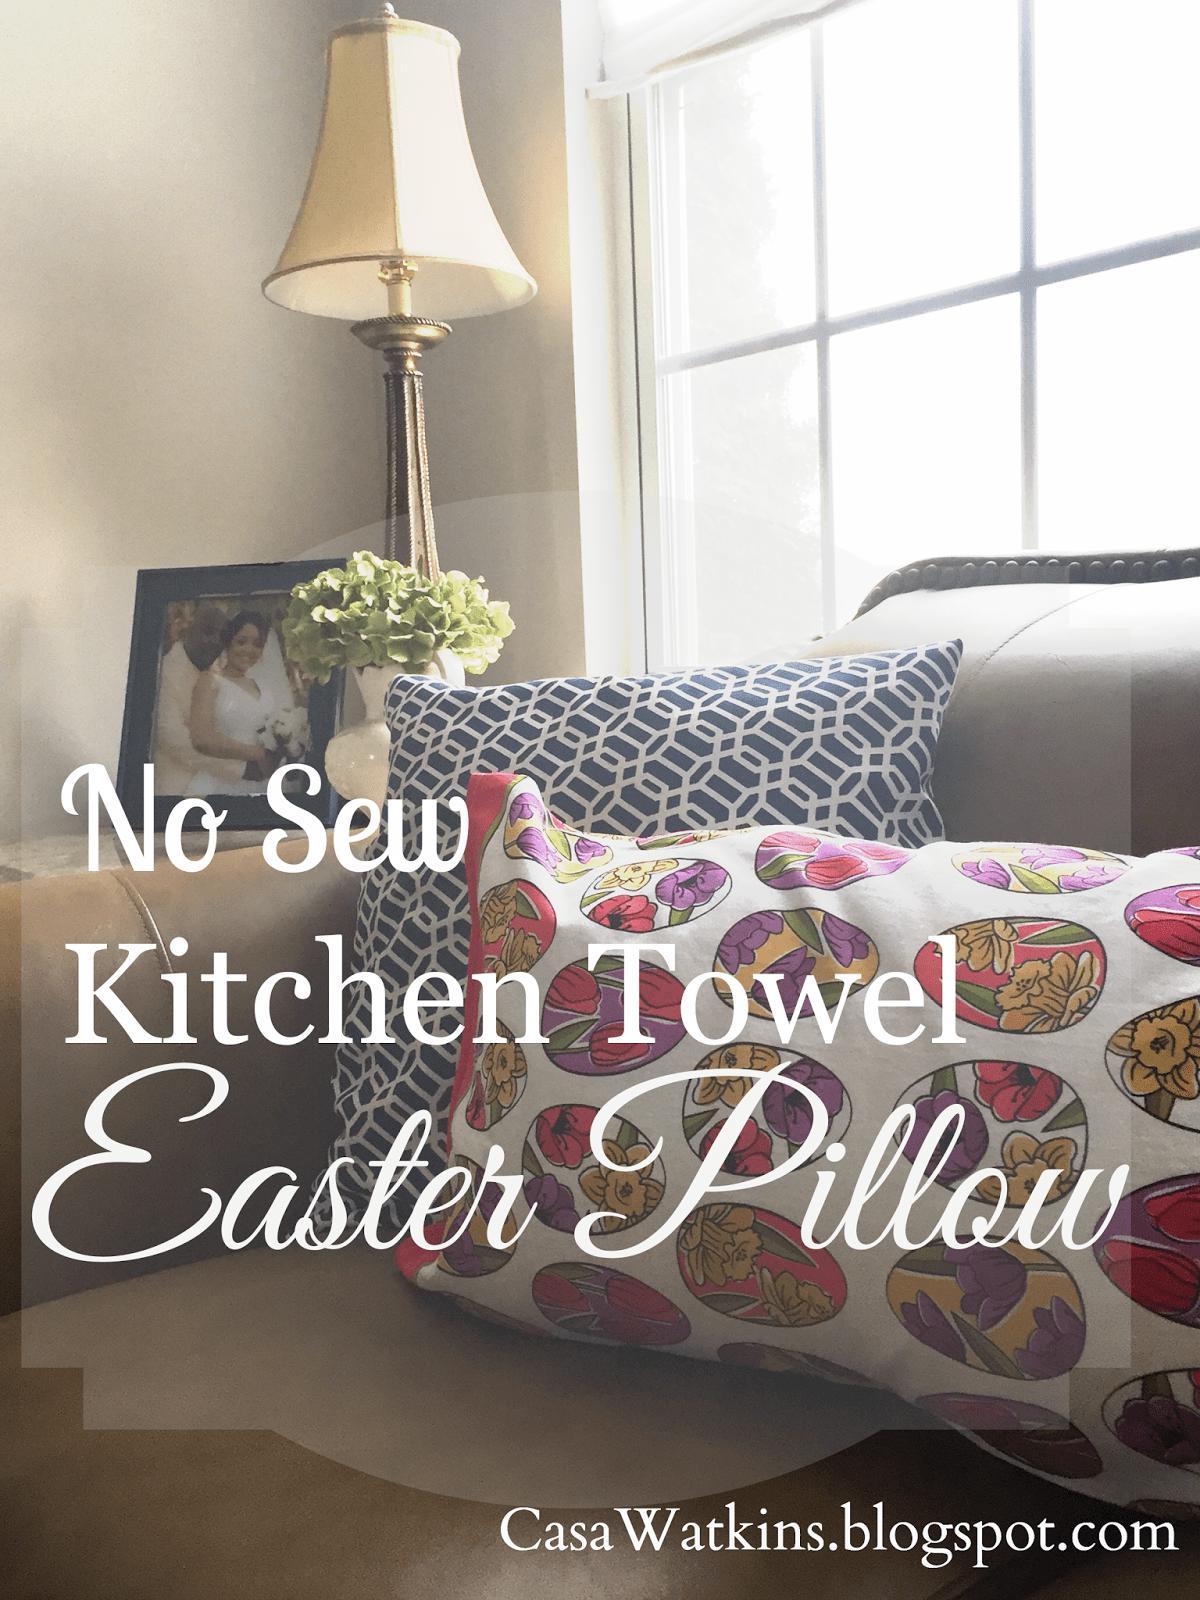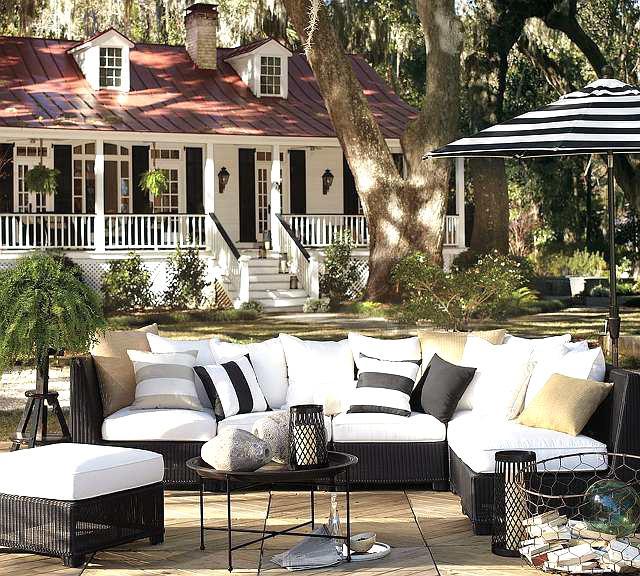The first image is the image on the left, the second image is the image on the right. Examine the images to the left and right. Is the description "One image includes at least one pillow decorated with animal silhouettes." accurate? Answer yes or no. No. The first image is the image on the left, the second image is the image on the right. For the images shown, is this caption "All images appear to be couches." true? Answer yes or no. Yes. 